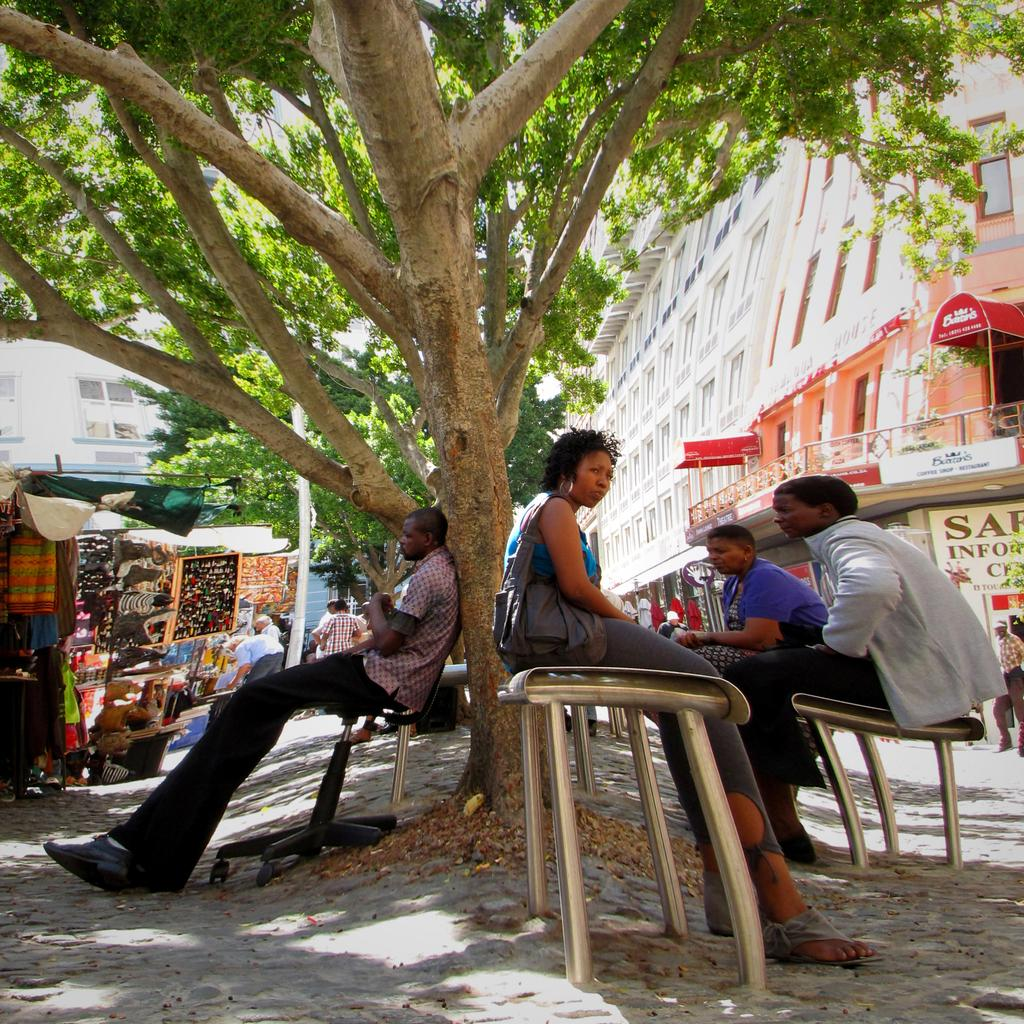What are the people in the image doing? The people in the image are sitting. Where are the people sitting in the image? The people are sitting under a tree. What else can be seen in the image besides the people sitting? There is a shopping stall and a building visible in the image. What type of donkey is present in the image? There is no donkey present in the image. How many brothers are sitting together in the image? There is no mention of brothers in the image, only people sitting. 